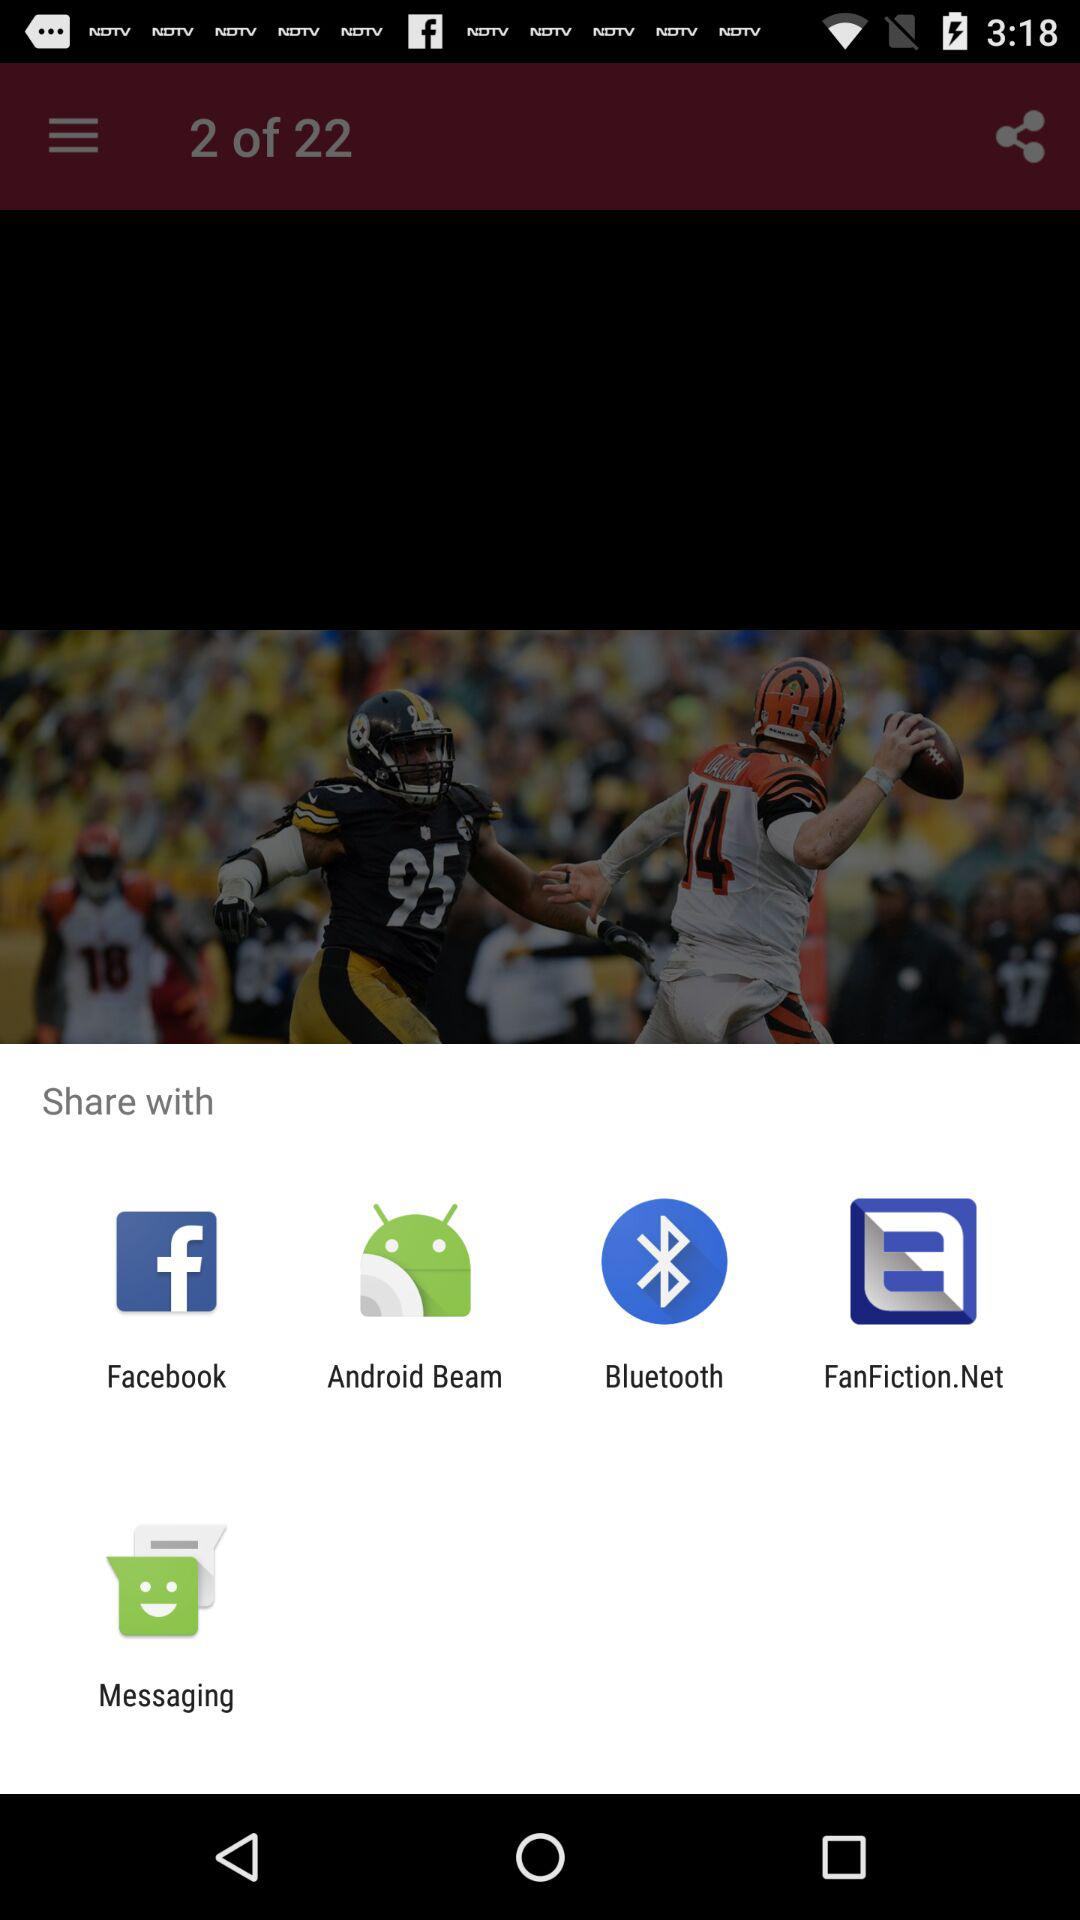How many items are in the share menu?
Answer the question using a single word or phrase. 5 